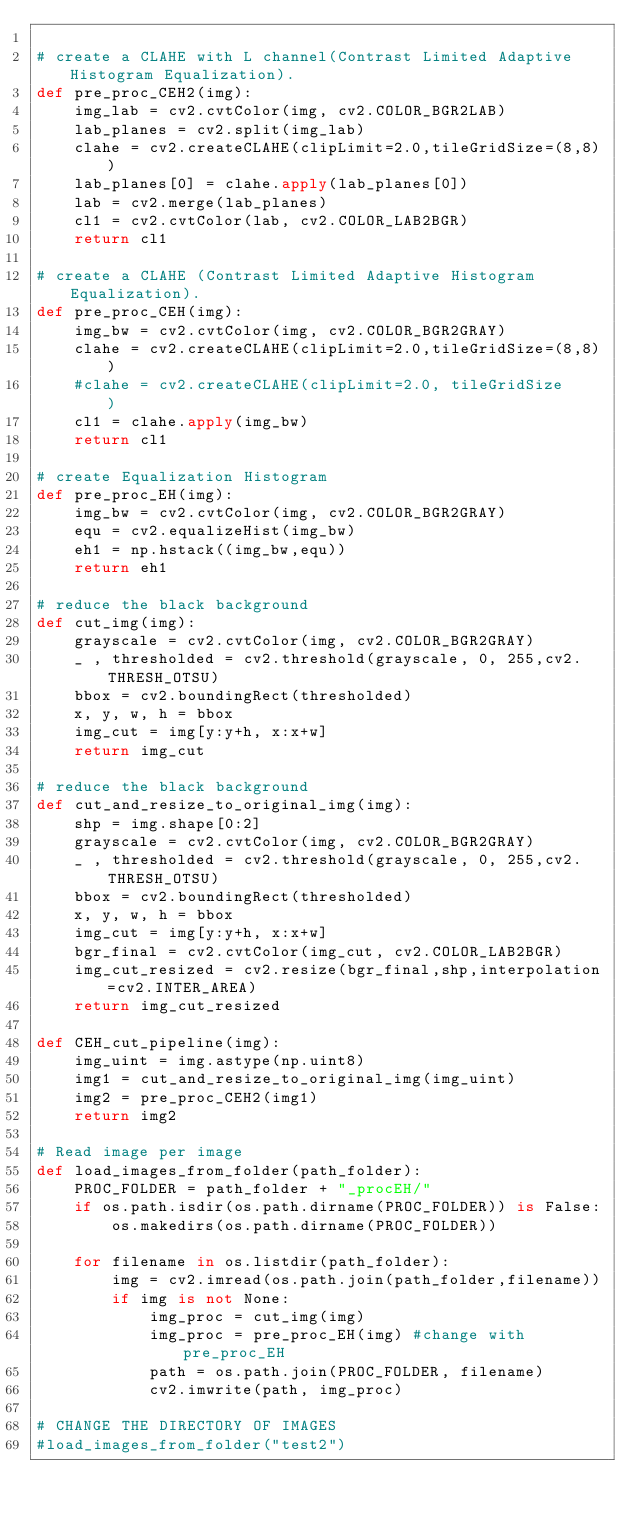Convert code to text. <code><loc_0><loc_0><loc_500><loc_500><_Python_>
# create a CLAHE with L channel(Contrast Limited Adaptive Histogram Equalization).
def pre_proc_CEH2(img): 
    img_lab = cv2.cvtColor(img, cv2.COLOR_BGR2LAB)
    lab_planes = cv2.split(img_lab)
    clahe = cv2.createCLAHE(clipLimit=2.0,tileGridSize=(8,8))
    lab_planes[0] = clahe.apply(lab_planes[0])
    lab = cv2.merge(lab_planes)
    cl1 = cv2.cvtColor(lab, cv2.COLOR_LAB2BGR)
    return cl1

# create a CLAHE (Contrast Limited Adaptive Histogram Equalization).	
def pre_proc_CEH(img):
    img_bw = cv2.cvtColor(img, cv2.COLOR_BGR2GRAY)    
    clahe = cv2.createCLAHE(clipLimit=2.0,tileGridSize=(8,8))
    #clahe = cv2.createCLAHE(clipLimit=2.0, tileGridSize	)
    cl1 = clahe.apply(img_bw)
    return cl1

# create Equalization Histogram
def pre_proc_EH(img):
    img_bw = cv2.cvtColor(img, cv2.COLOR_BGR2GRAY)
    equ = cv2.equalizeHist(img_bw)
    eh1 = np.hstack((img_bw,equ))
    return eh1

# reduce the black background
def cut_img(img):
    grayscale = cv2.cvtColor(img, cv2.COLOR_BGR2GRAY)
    _ , thresholded = cv2.threshold(grayscale, 0, 255,cv2.THRESH_OTSU)
    bbox = cv2.boundingRect(thresholded)
    x, y, w, h = bbox
    img_cut = img[y:y+h, x:x+w]    
    return img_cut

# reduce the black background
def cut_and_resize_to_original_img(img):
    shp = img.shape[0:2]
    grayscale = cv2.cvtColor(img, cv2.COLOR_BGR2GRAY)
    _ , thresholded = cv2.threshold(grayscale, 0, 255,cv2.THRESH_OTSU)
    bbox = cv2.boundingRect(thresholded)
    x, y, w, h = bbox
    img_cut = img[y:y+h, x:x+w]    
    bgr_final = cv2.cvtColor(img_cut, cv2.COLOR_LAB2BGR)
    img_cut_resized = cv2.resize(bgr_final,shp,interpolation=cv2.INTER_AREA)
    return img_cut_resized

def CEH_cut_pipeline(img):
    img_uint = img.astype(np.uint8)
    img1 = cut_and_resize_to_original_img(img_uint)
    img2 = pre_proc_CEH2(img1)
    return img2

# Read image per image
def load_images_from_folder(path_folder): 
    PROC_FOLDER = path_folder + "_procEH/"
    if os.path.isdir(os.path.dirname(PROC_FOLDER)) is False:
        os.makedirs(os.path.dirname(PROC_FOLDER))

    for filename in os.listdir(path_folder):
        img = cv2.imread(os.path.join(path_folder,filename))
        if img is not None:
            img_proc = cut_img(img)
            img_proc = pre_proc_EH(img) #change with pre_proc_EH
            path = os.path.join(PROC_FOLDER, filename)
            cv2.imwrite(path, img_proc)

# CHANGE THE DIRECTORY OF IMAGES
#load_images_from_folder("test2")
</code> 